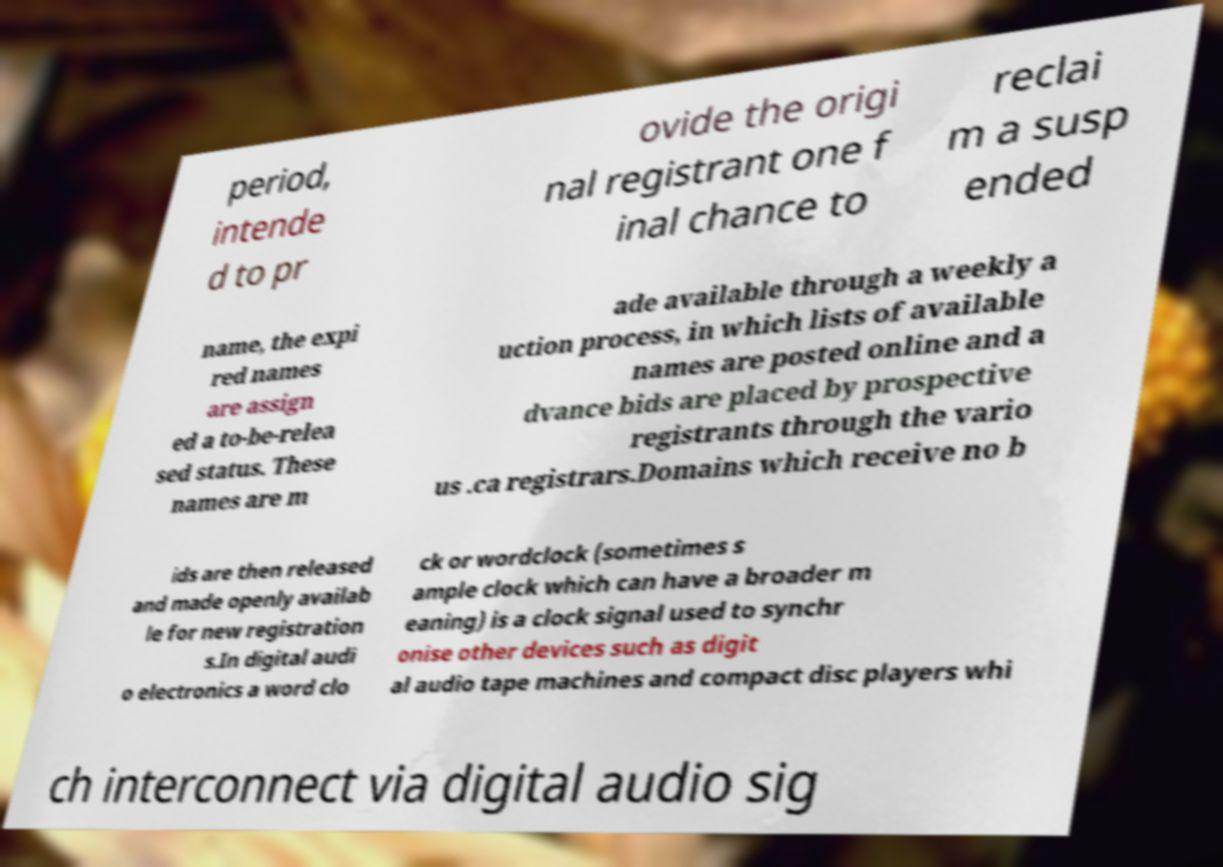I need the written content from this picture converted into text. Can you do that? period, intende d to pr ovide the origi nal registrant one f inal chance to reclai m a susp ended name, the expi red names are assign ed a to-be-relea sed status. These names are m ade available through a weekly a uction process, in which lists of available names are posted online and a dvance bids are placed by prospective registrants through the vario us .ca registrars.Domains which receive no b ids are then released and made openly availab le for new registration s.In digital audi o electronics a word clo ck or wordclock (sometimes s ample clock which can have a broader m eaning) is a clock signal used to synchr onise other devices such as digit al audio tape machines and compact disc players whi ch interconnect via digital audio sig 